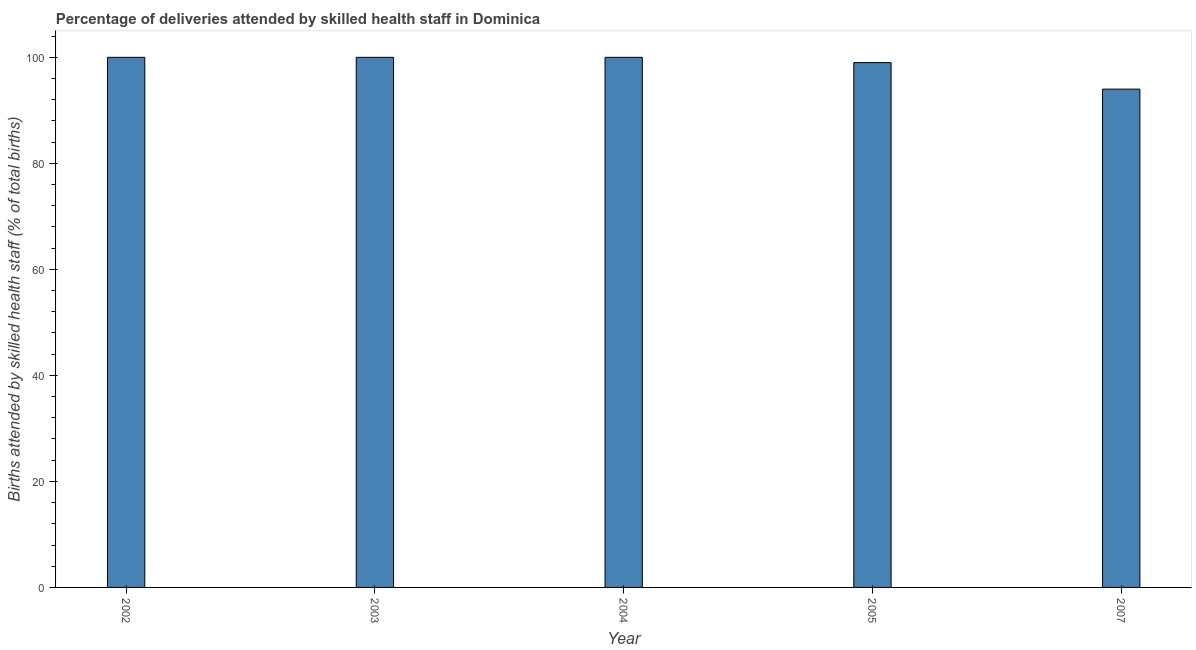What is the title of the graph?
Ensure brevity in your answer.  Percentage of deliveries attended by skilled health staff in Dominica. What is the label or title of the X-axis?
Offer a terse response. Year. What is the label or title of the Y-axis?
Your answer should be compact. Births attended by skilled health staff (% of total births). What is the number of births attended by skilled health staff in 2002?
Provide a succinct answer. 100. Across all years, what is the minimum number of births attended by skilled health staff?
Provide a short and direct response. 94. What is the sum of the number of births attended by skilled health staff?
Your answer should be compact. 493. What is the difference between the number of births attended by skilled health staff in 2004 and 2005?
Offer a very short reply. 1. What is the average number of births attended by skilled health staff per year?
Offer a very short reply. 98.6. What is the median number of births attended by skilled health staff?
Offer a very short reply. 100. In how many years, is the number of births attended by skilled health staff greater than 88 %?
Offer a very short reply. 5. What is the ratio of the number of births attended by skilled health staff in 2002 to that in 2004?
Your answer should be compact. 1. Is the sum of the number of births attended by skilled health staff in 2002 and 2005 greater than the maximum number of births attended by skilled health staff across all years?
Your answer should be compact. Yes. What is the difference between the highest and the lowest number of births attended by skilled health staff?
Provide a short and direct response. 6. In how many years, is the number of births attended by skilled health staff greater than the average number of births attended by skilled health staff taken over all years?
Make the answer very short. 4. How many years are there in the graph?
Ensure brevity in your answer.  5. What is the difference between two consecutive major ticks on the Y-axis?
Make the answer very short. 20. Are the values on the major ticks of Y-axis written in scientific E-notation?
Your answer should be compact. No. What is the Births attended by skilled health staff (% of total births) of 2002?
Provide a succinct answer. 100. What is the Births attended by skilled health staff (% of total births) of 2003?
Keep it short and to the point. 100. What is the Births attended by skilled health staff (% of total births) in 2007?
Your answer should be very brief. 94. What is the difference between the Births attended by skilled health staff (% of total births) in 2002 and 2005?
Your answer should be very brief. 1. What is the difference between the Births attended by skilled health staff (% of total births) in 2003 and 2005?
Provide a short and direct response. 1. What is the difference between the Births attended by skilled health staff (% of total births) in 2004 and 2007?
Offer a very short reply. 6. What is the ratio of the Births attended by skilled health staff (% of total births) in 2002 to that in 2003?
Offer a terse response. 1. What is the ratio of the Births attended by skilled health staff (% of total births) in 2002 to that in 2005?
Your response must be concise. 1.01. What is the ratio of the Births attended by skilled health staff (% of total births) in 2002 to that in 2007?
Provide a succinct answer. 1.06. What is the ratio of the Births attended by skilled health staff (% of total births) in 2003 to that in 2004?
Provide a short and direct response. 1. What is the ratio of the Births attended by skilled health staff (% of total births) in 2003 to that in 2007?
Offer a very short reply. 1.06. What is the ratio of the Births attended by skilled health staff (% of total births) in 2004 to that in 2007?
Ensure brevity in your answer.  1.06. What is the ratio of the Births attended by skilled health staff (% of total births) in 2005 to that in 2007?
Give a very brief answer. 1.05. 